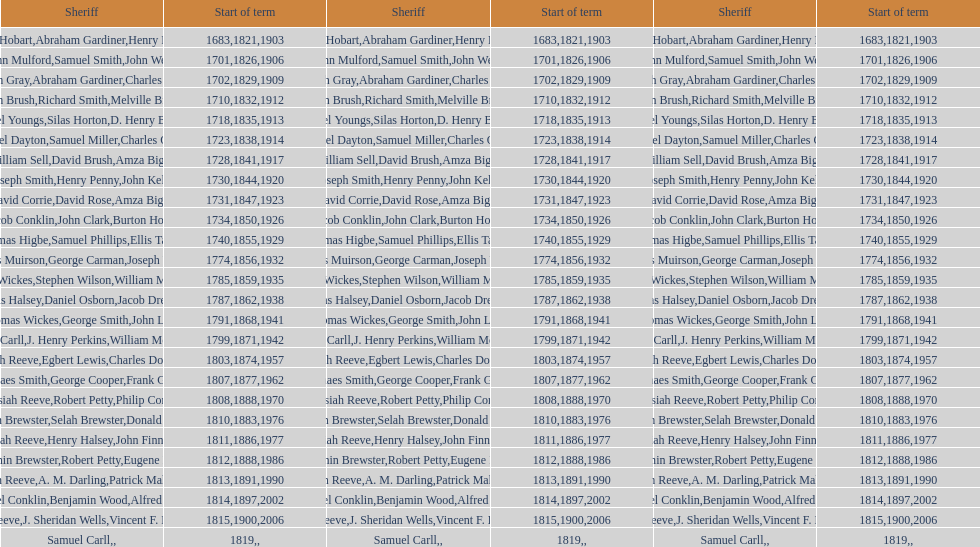How many sheriff's have the last name biggs? 1. 